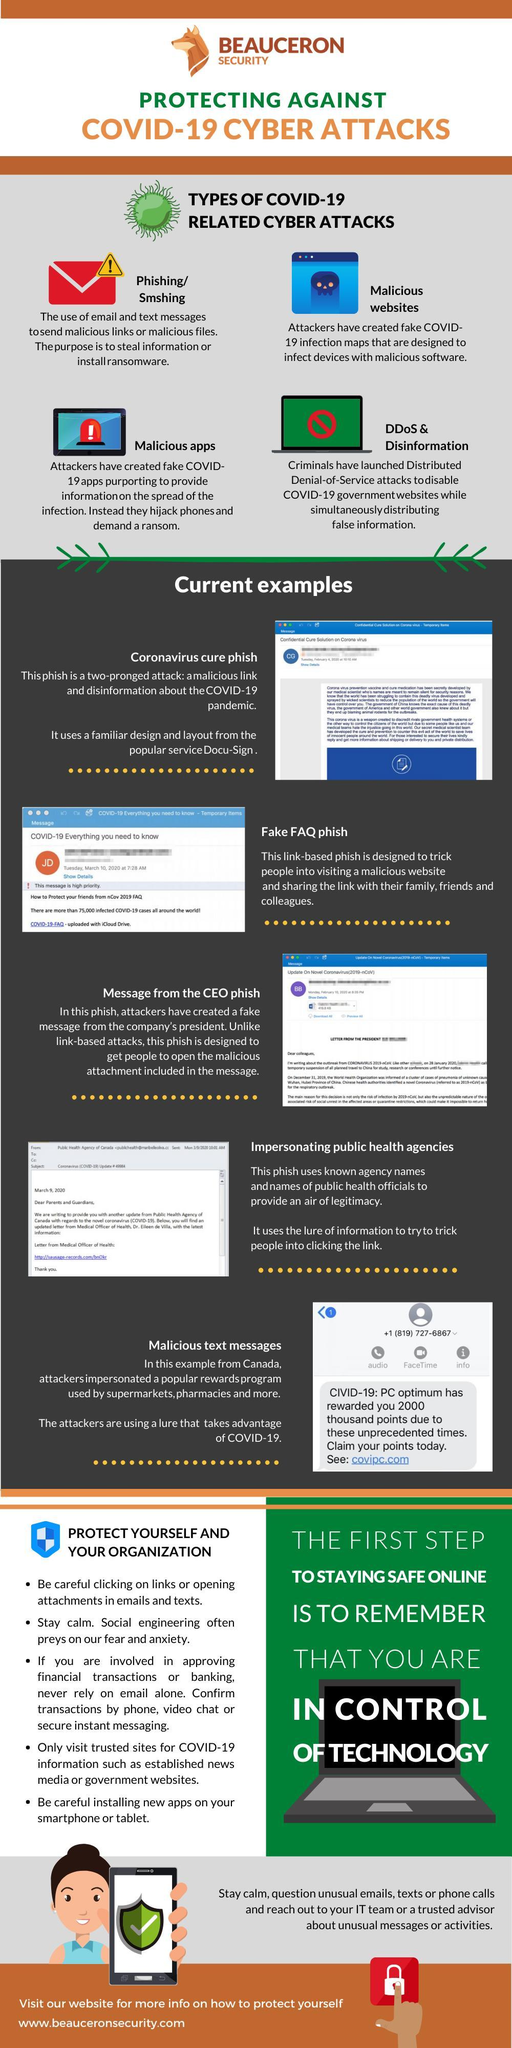What is the first step to staying safe online?
Answer the question with a short phrase. To remember that you are in control of technology How many bullet points are there under 'protect yourself and your organisation'? 5 Which is the fourth type of covid-19 related cyber attack mentioned? DDoS & Disinformation Which type of Cyber attacks use email and text messages to send a malicious links? Phishing/Smshing How many types of covid-19 related cyber attacks are mentioned here? 4 Which type of Cyber attack includes creating fake maps designed to infect the device with malicious software? Malicious websites How many 'examples' of phishing are mentioned here? 5 Which are the first three examples of phishing? Coronavirus cure phish, fake FAQ phish, message from the CEO phish Which type of Cyber attacks mentioned here, includes creating fake apps for hijacking phones? Malicious apps 